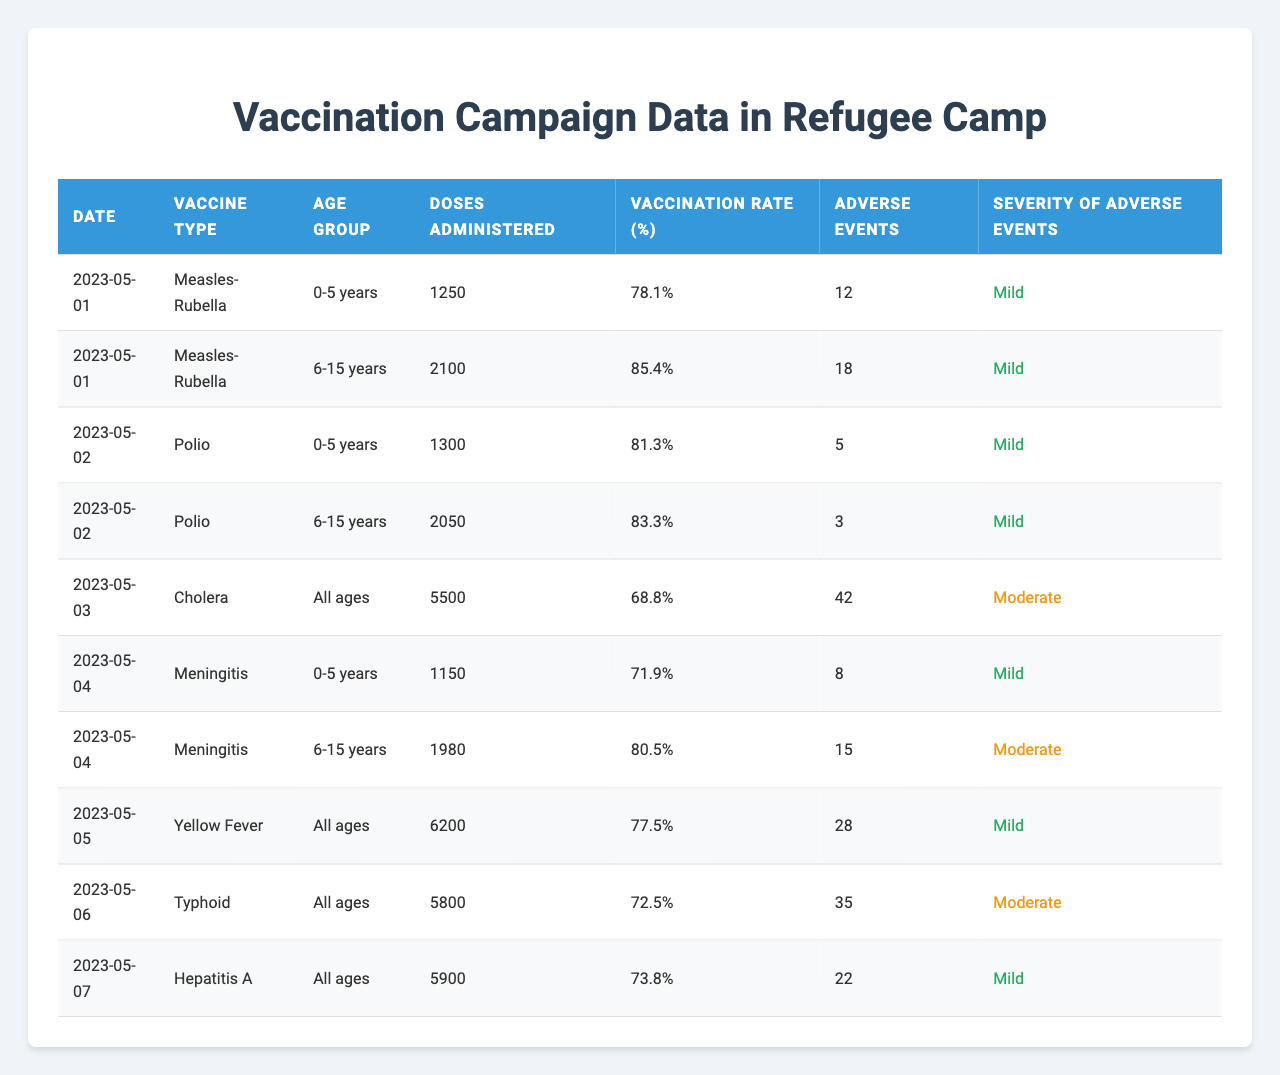What is the vaccination rate for the "Yellow Fever" vaccine? In the table, I can find the row corresponding to "Yellow Fever," which shows a vaccination rate of 77.5%.
Answer: 77.5% How many doses of "Meningitis" were administered to the "6-15 years" age group? By looking at the table, I see that for "Meningitis" in the "6-15 years" age group, 1980 doses were administered.
Answer: 1980 What was the highest number of adverse events reported for a single vaccine? Scanning through the table, the most significant number of adverse events is 42 for "Cholera" on 2023-05-03.
Answer: 42 What is the average vaccination rate across all vaccine types administered in the camp? To calculate the average, I add the vaccination rates: (78.1 + 85.4 + 81.3 + 83.3 + 68.8 + 71.9 + 80.5 + 77.5 + 72.5 + 73.8) =  794.1. There are 10 records, so the average is 794.1 / 10 = 79.41%.
Answer: 79.41% For the "0-5 years" age group, which vaccine had the highest adverse events? Focus on the rows for the "0-5 years" age group: Measles-Rubella has 12, Polio has 5, Meningitis has 8, and Cholera has no entries. The highest is 12 for Measles-Rubella.
Answer: Measles-Rubella Did any vaccine lead to "Severe" adverse events? Checking the severity column, all adverse events categorized are either "Mild" or "Moderate." No severe events are reported.
Answer: No Which age group had the highest vaccination rate overall? I analyze the vaccination rates by age groups. The highest overall vaccination rate is seen in the "6-15 years" category with 85.4% for "Measles-Rubella."
Answer: 6-15 years How do the adverse events of "Polio" compare to "Typhoid"? From the table, "Polio" had 5 adverse events, while "Typhoid" had 35 adverse events. This indicates "Typhoid" had more adverse events than "Polio."
Answer: Typhoid had more What percentage of adverse events were categorized as "Moderate"? By counting from the table, there are 3 moderate adverse events for Polio, 15 for Meningitis, 28 for Yellow Fever, and 35 for Typhoid, totalling 81 out of 109 adverse events overall. The percentage is (81 / 109) * 100 = 74.31%.
Answer: 74.31% Which date had the lowest vaccination rate, and for what vaccine? Looking through the vaccination rates, "Cholera" on 2023-05-03 has the lowest at 68.8%.
Answer: 2023-05-03, Cholera Are there more doses administered for vaccines for "All ages" or for specific age groups? Total doses for "All ages" are 5500 (Cholera) + 6200 (Yellow Fever) + 5800 (Typhoid) = 18,500. For specific age groups, total doses are less than this since they only pertain to 0-5 and 6-15 years.
Answer: More for All ages 